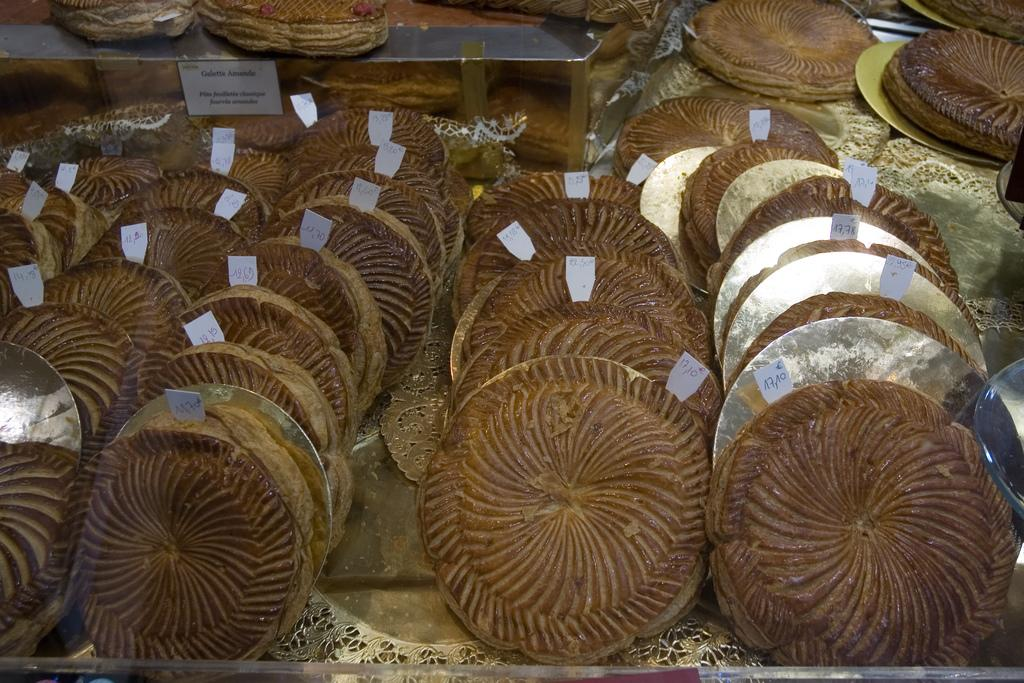What types of items can be seen in the image? There are food items in the image. How can the cost of the food items be determined? The food items have price tags on them. How are the food items arranged or displayed in the image? The food items are placed on trays. What size is the park mentioned in the caption of the image? There is no park or caption mentioned in the image; it only features food items with price tags on trays. 